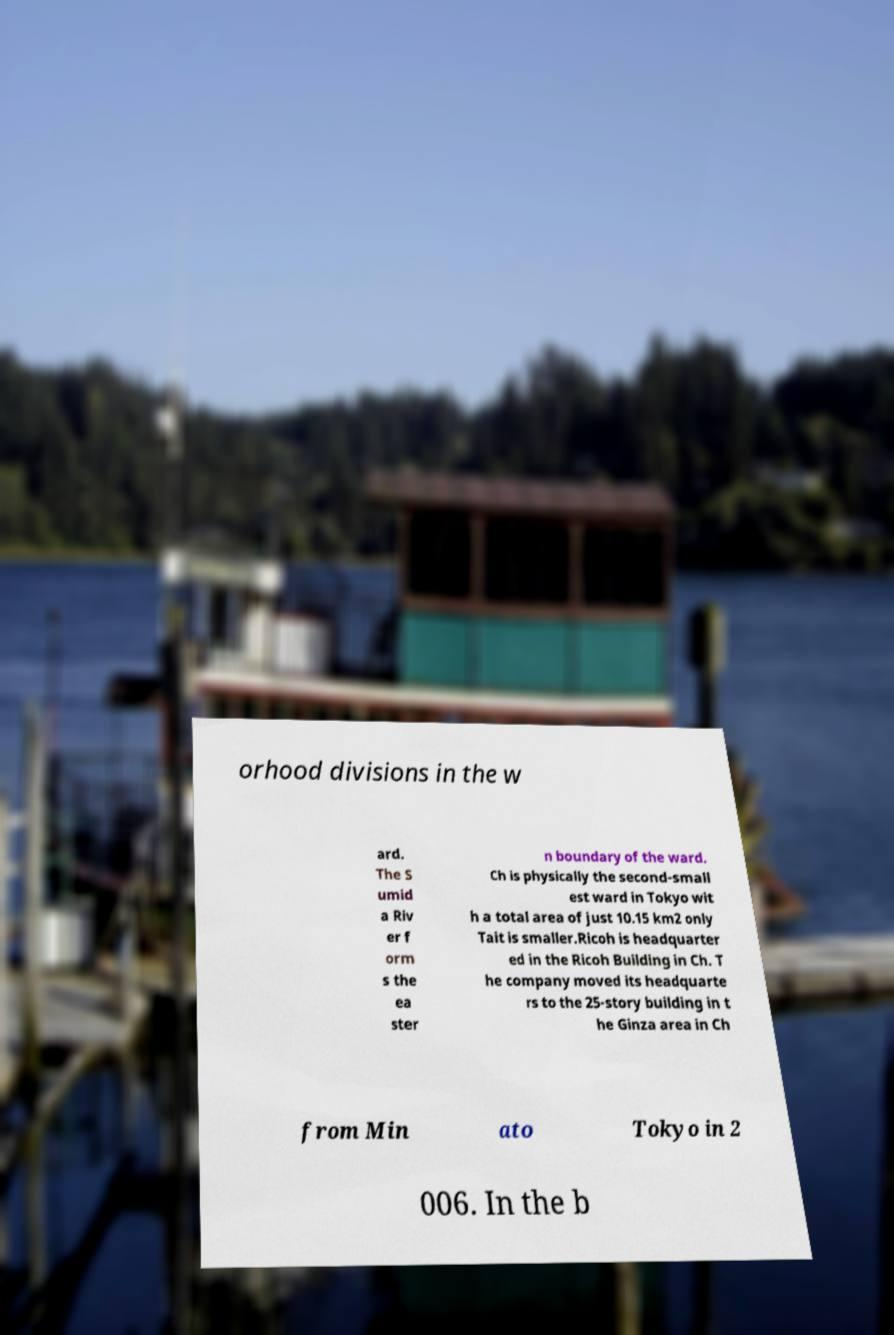For documentation purposes, I need the text within this image transcribed. Could you provide that? orhood divisions in the w ard. The S umid a Riv er f orm s the ea ster n boundary of the ward. Ch is physically the second-small est ward in Tokyo wit h a total area of just 10.15 km2 only Tait is smaller.Ricoh is headquarter ed in the Ricoh Building in Ch. T he company moved its headquarte rs to the 25-story building in t he Ginza area in Ch from Min ato Tokyo in 2 006. In the b 